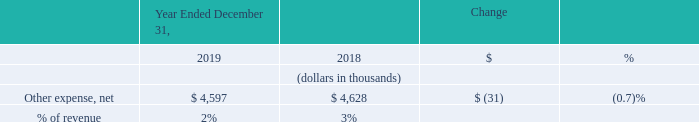Other Income (Expense), Net
Other expense, net decreased by $31 thousand in 2019 compared to 2018 as a result of the recognition of a $1.4 million loss on extinguishment related to the partial repurchase of our 2022 Notes and a $1.1 million increase in interest expense related to our convertible senior notes, offset by an increase of $2.7 million of interest income earned on our investment as a result of proceeds invested from our convertible note and common stock offerings.
What was the decrease in the Other net expense in 2019? $31 thousand. What was the increase in interest income? $2.7 million. What was the % of revenue in 2019 and 2018?
Answer scale should be: percent. 2, 3. What was the average Other expense, net for 2018 and 2019?
Answer scale should be: thousand. (4,597 + 4,628) / 2
Answer: 4612.5. In which year was Other expense, net less than 5,000 thousands? Locate and analyze the other expenses in row 4
answer: 2019, 2018. What is the change in the % of revenue from 2018 to 2019?
Answer scale should be: percent. 2 - 3
Answer: -1. 